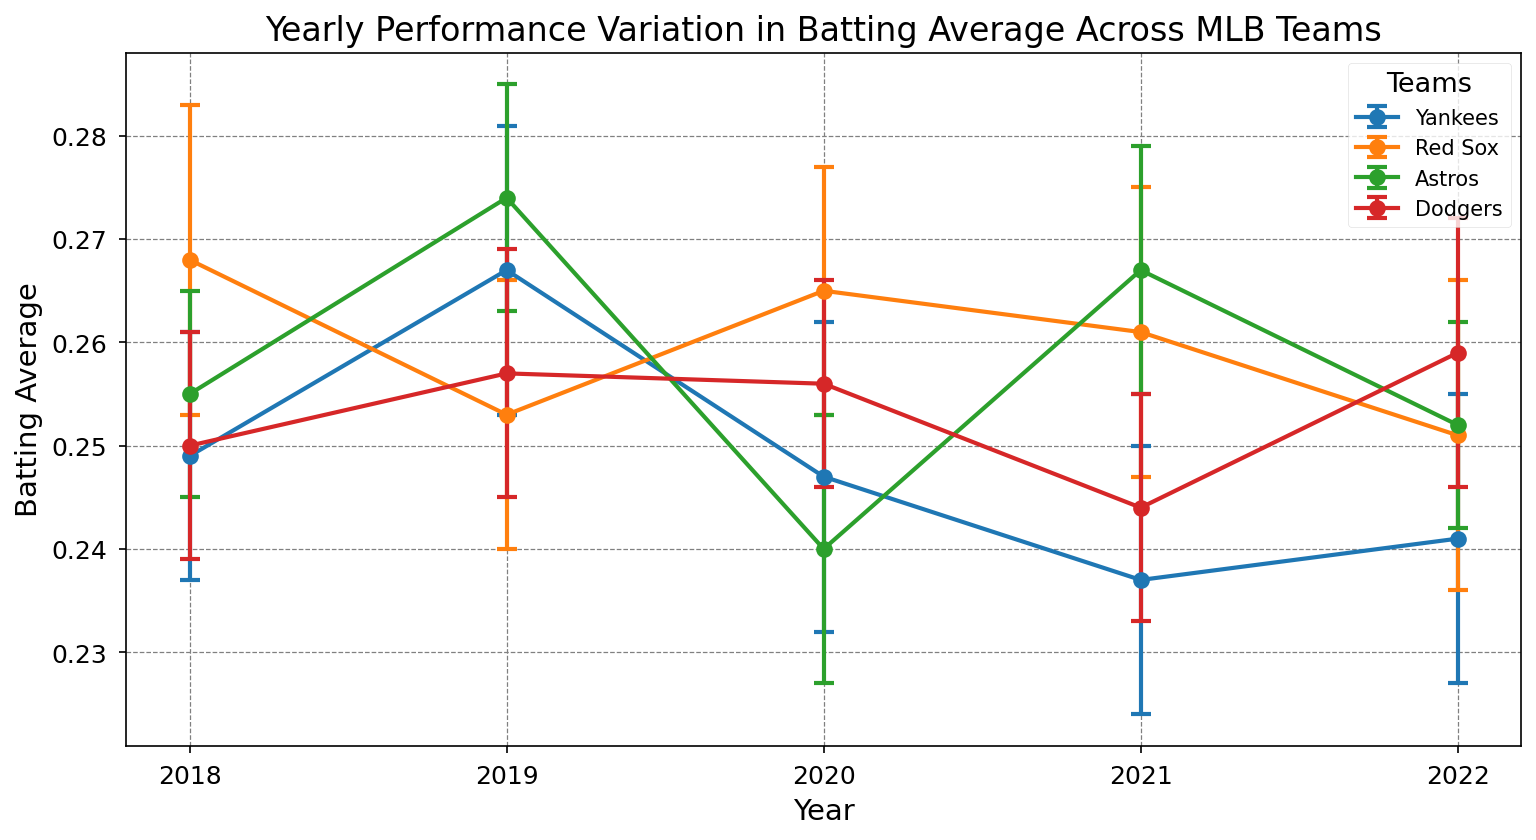Which team had the highest batting average in 2018? To find the team with the highest batting average in 2018, look at the error bars for each team and identify the highest mean value. The Red Sox had the highest average in 2018 at 0.268.
Answer: Red Sox How did the batting average of the Yankees change from 2018 to 2022? Compare the batting averages for the Yankees in 2018 and in 2022. In 2018, the Yankees had an average of 0.249, while in 2022, their average was 0.241. They experienced a decrease of 0.008 in batting average.
Answer: Decreased by 0.008 Which team displayed the most consistent performance over the years? Consistency can be inferred by examining the length of the error bars and the fluctuation of the average values year by year. The Astros show smaller error bars overall and less fluctuation, indicating consistent performance.
Answer: Astros What's the compositional difference between the highest batting average in 2019 and the lowest in 2019? Identify the highest batting average in 2019 (Astros with 0.274) and the lowest (Red Sox with 0.253). Calculate the difference: 0.274 - 0.253 = 0.021.
Answer: 0.021 In which year did the Dodgers have their highest average batting performance? Look for the highest batting average value for the Dodgers across the years. Their highest average was in 2022 with 0.259.
Answer: 2022 Which team showed the most improvement from 2021 to 2022? Compare each team's batting average between 2021 and 2022 to see which team had the greatest positive change. The Dodgers improved from 0.244 in 2021 to 0.259 in 2022, which is an increase of 0.015.
Answer: Dodgers How did the Red Sox batting average trend generally from 2018 to 2022? Examine the Red Sox yearly averages: 0.268 (2018), 0.253 (2019), 0.265 (2020), 0.261 (2021), and 0.251 (2022). The trend shows a general decrease over time.
Answer: Decreasing Compare the error bars for the Yankees and Astros in 2020. Which team had more variability? Examine the length of the error bars for both teams in 2020. The Yankees had an error of 0.015, while the Astros had an error of 0.013, indicating the Yankees had more variability.
Answer: Yankees Did any team's batting average remain constant over consecutive years? Analyze the batting average for all teams year by year to see if any team had the same average in consecutive years. None of the teams had a constant batting average over consecutive years.
Answer: No 